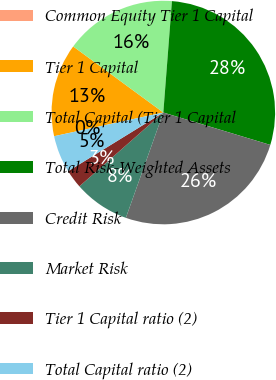<chart> <loc_0><loc_0><loc_500><loc_500><pie_chart><fcel>Common Equity Tier 1 Capital<fcel>Tier 1 Capital<fcel>Total Capital (Tier 1 Capital<fcel>Total Risk-Weighted Assets<fcel>Credit Risk<fcel>Market Risk<fcel>Tier 1 Capital ratio (2)<fcel>Total Capital ratio (2)<nl><fcel>0.0%<fcel>13.47%<fcel>16.16%<fcel>28.45%<fcel>25.76%<fcel>8.08%<fcel>2.69%<fcel>5.39%<nl></chart> 